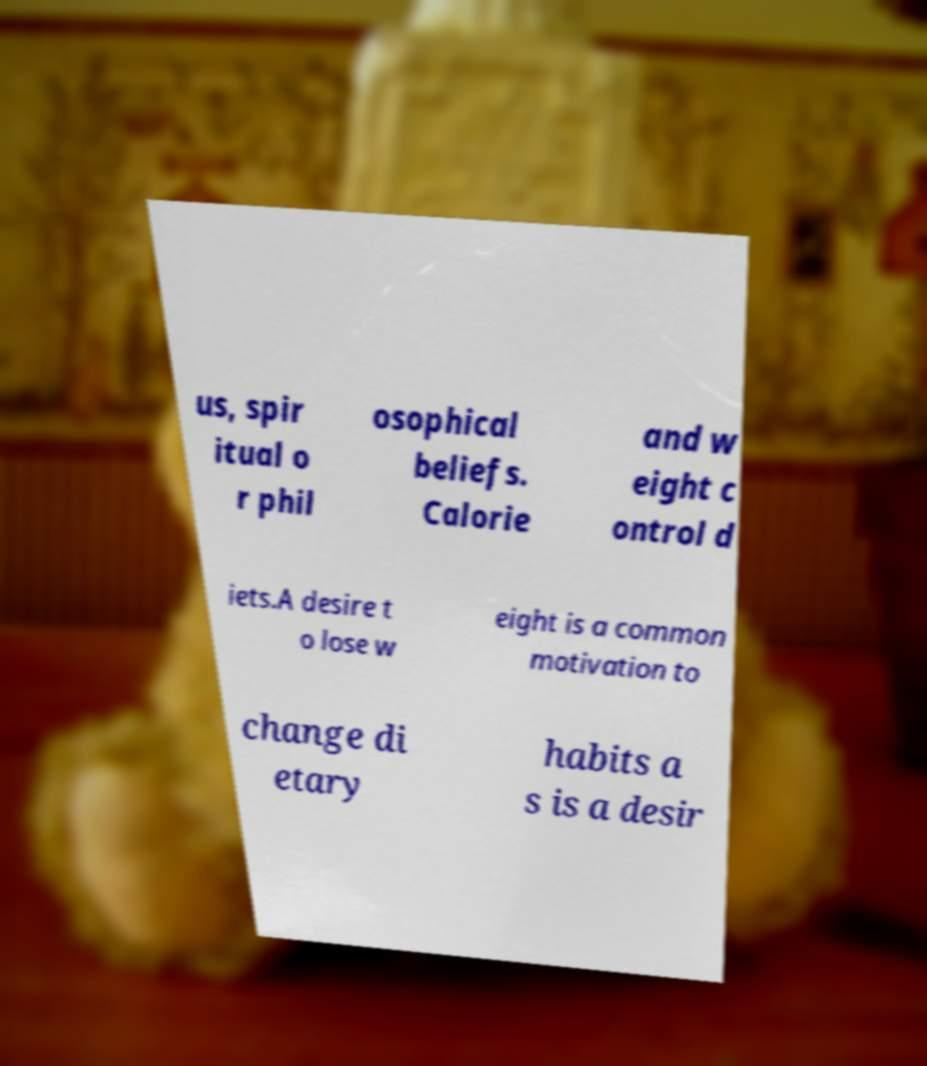There's text embedded in this image that I need extracted. Can you transcribe it verbatim? us, spir itual o r phil osophical beliefs. Calorie and w eight c ontrol d iets.A desire t o lose w eight is a common motivation to change di etary habits a s is a desir 